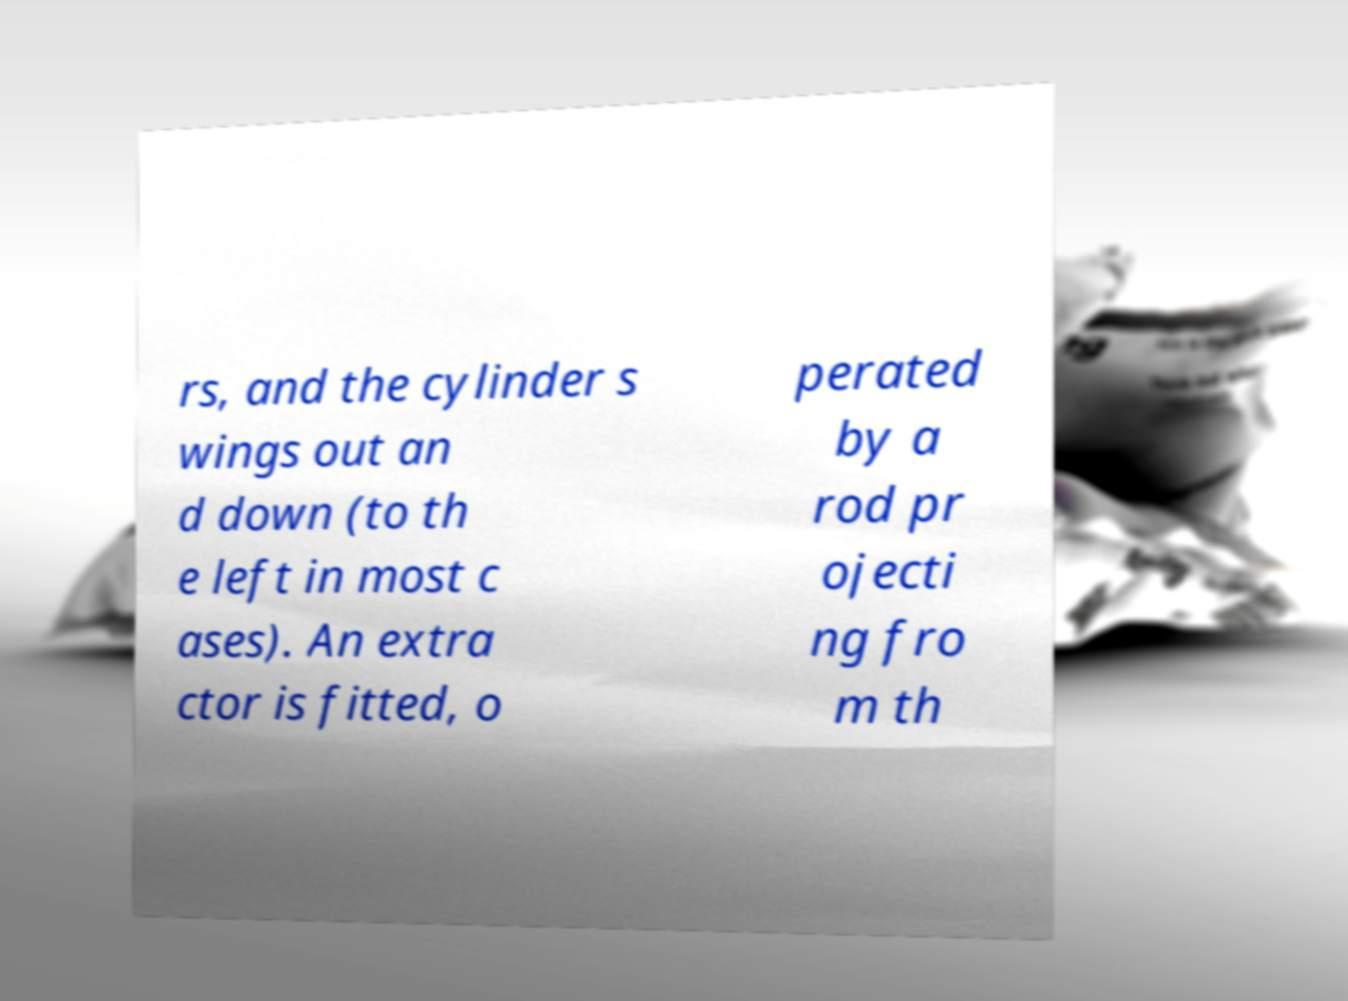I need the written content from this picture converted into text. Can you do that? rs, and the cylinder s wings out an d down (to th e left in most c ases). An extra ctor is fitted, o perated by a rod pr ojecti ng fro m th 